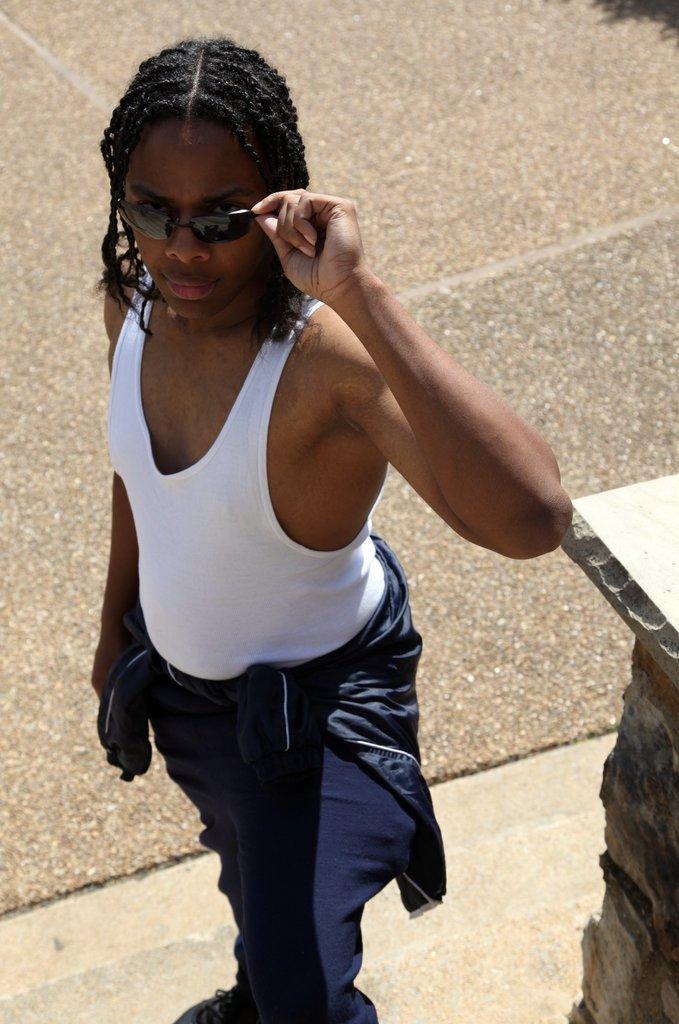Could you give a brief overview of what you see in this image? This image consists of a person standing. He is wearing shades. At the bottom, there is a road. To the right, there is a pillar. 